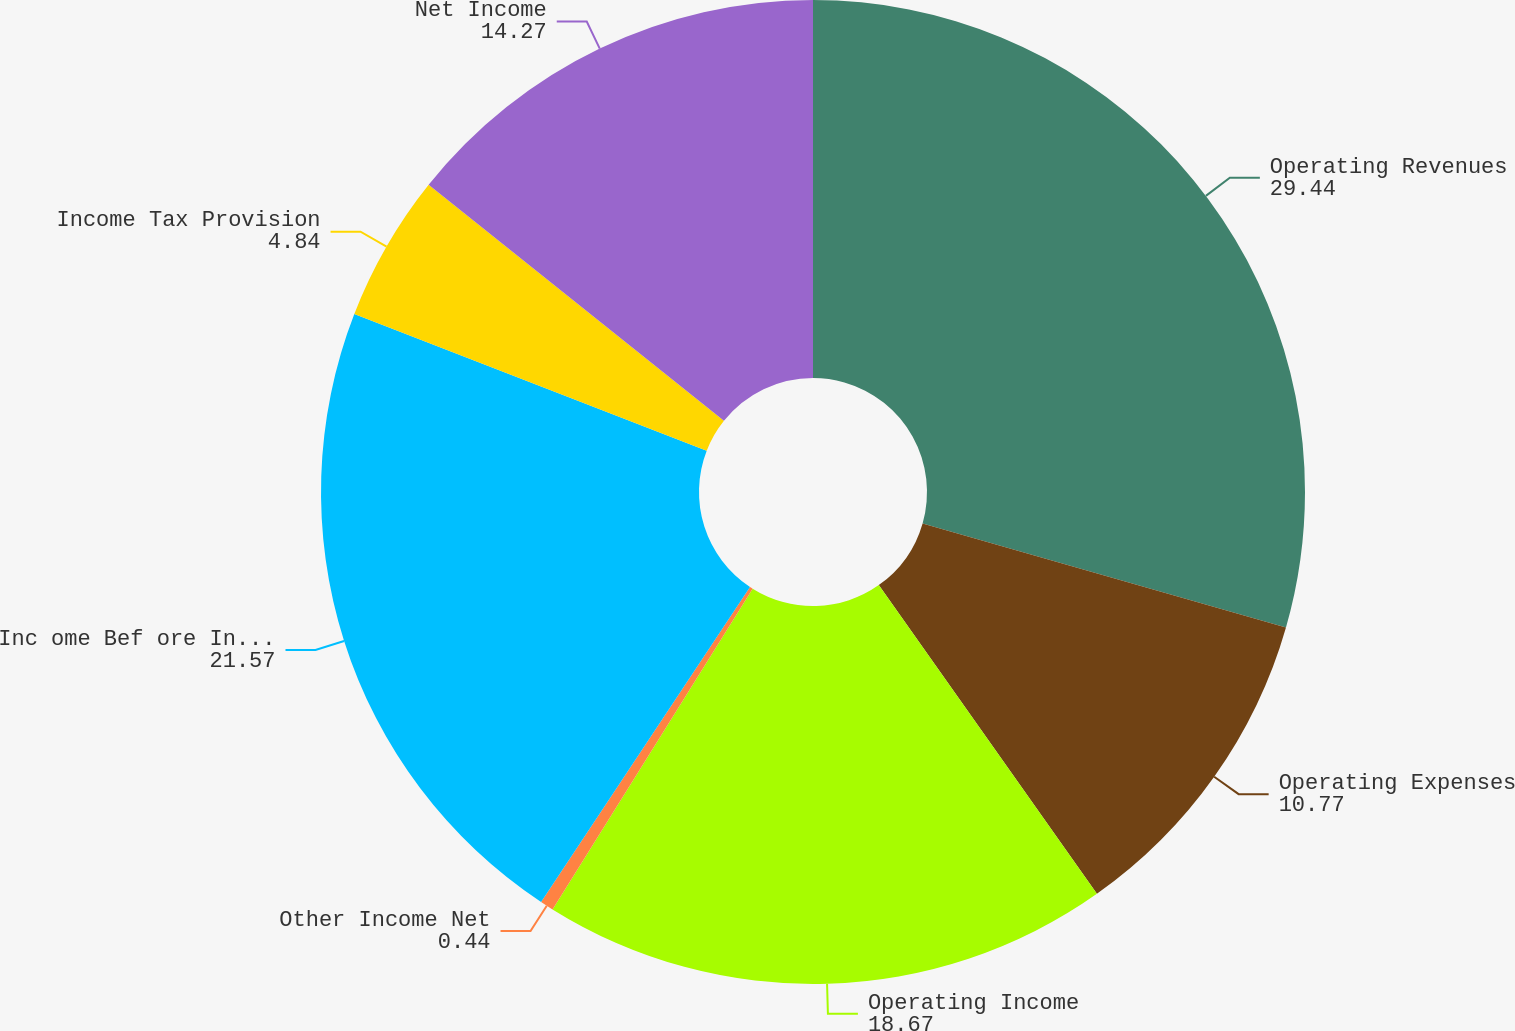<chart> <loc_0><loc_0><loc_500><loc_500><pie_chart><fcel>Operating Revenues<fcel>Operating Expenses<fcel>Operating Income<fcel>Other Income Net<fcel>Inc ome Bef ore Inc ome Tax es<fcel>Income Tax Provision<fcel>Net Income<nl><fcel>29.44%<fcel>10.77%<fcel>18.67%<fcel>0.44%<fcel>21.57%<fcel>4.84%<fcel>14.27%<nl></chart> 